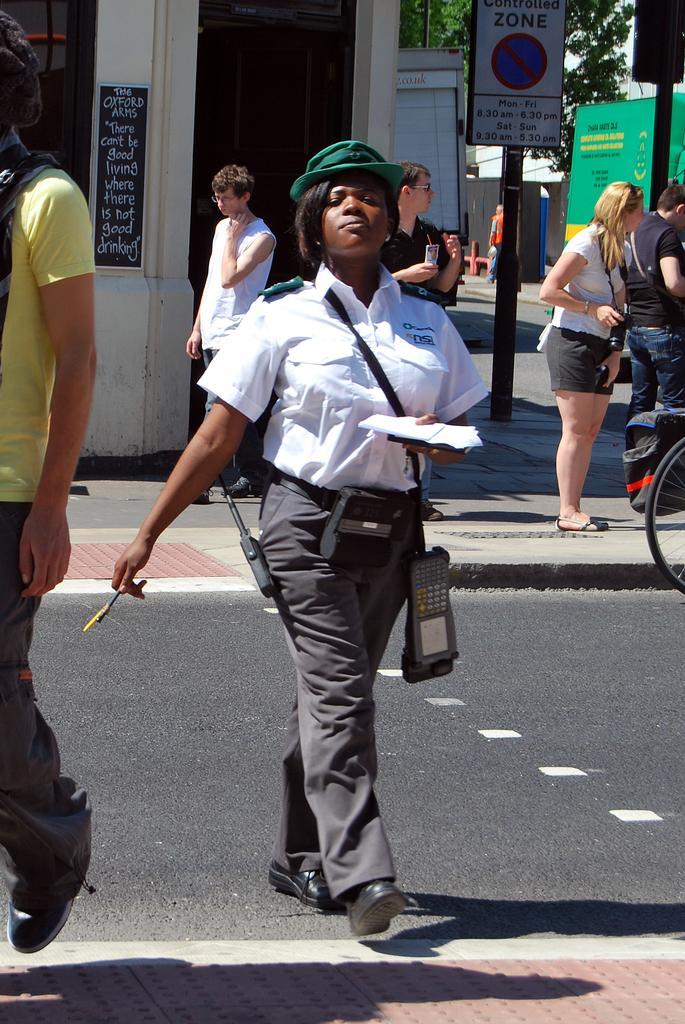In one or two sentences, can you explain what this image depicts? In front of the image there are two people walking on the road. Behind them there are a few other people standing. There are boards, hoardings. On the right side of the image there is some object on the cycle. In the background of the image there are buildings, trees. 